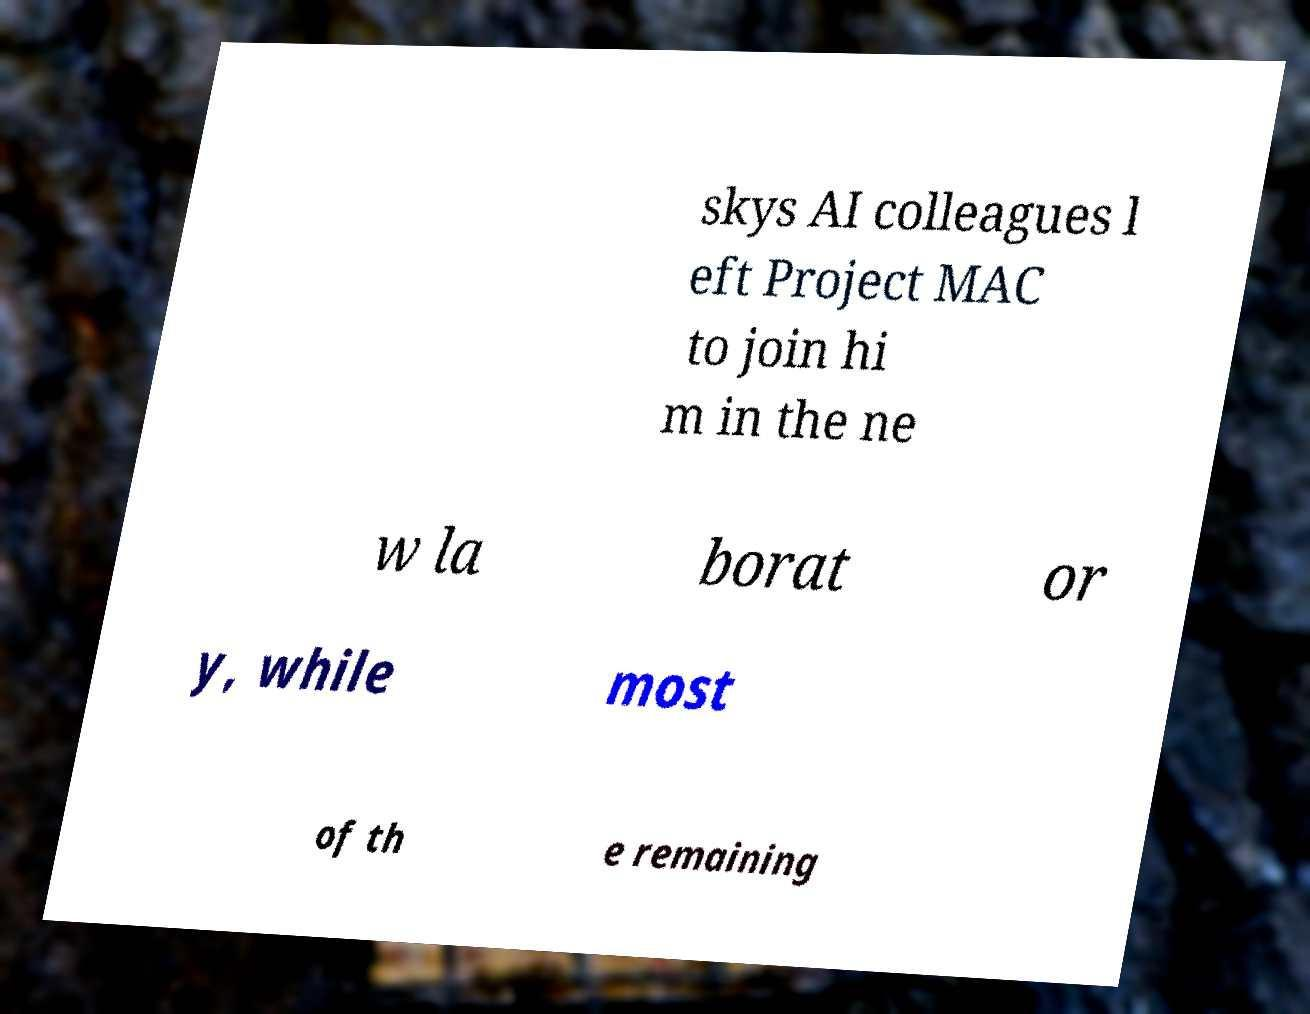Please identify and transcribe the text found in this image. skys AI colleagues l eft Project MAC to join hi m in the ne w la borat or y, while most of th e remaining 